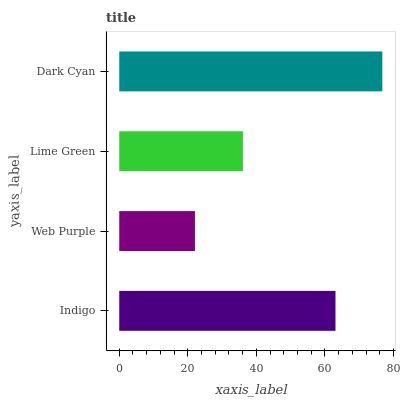Is Web Purple the minimum?
Answer yes or no. Yes. Is Dark Cyan the maximum?
Answer yes or no. Yes. Is Lime Green the minimum?
Answer yes or no. No. Is Lime Green the maximum?
Answer yes or no. No. Is Lime Green greater than Web Purple?
Answer yes or no. Yes. Is Web Purple less than Lime Green?
Answer yes or no. Yes. Is Web Purple greater than Lime Green?
Answer yes or no. No. Is Lime Green less than Web Purple?
Answer yes or no. No. Is Indigo the high median?
Answer yes or no. Yes. Is Lime Green the low median?
Answer yes or no. Yes. Is Web Purple the high median?
Answer yes or no. No. Is Web Purple the low median?
Answer yes or no. No. 